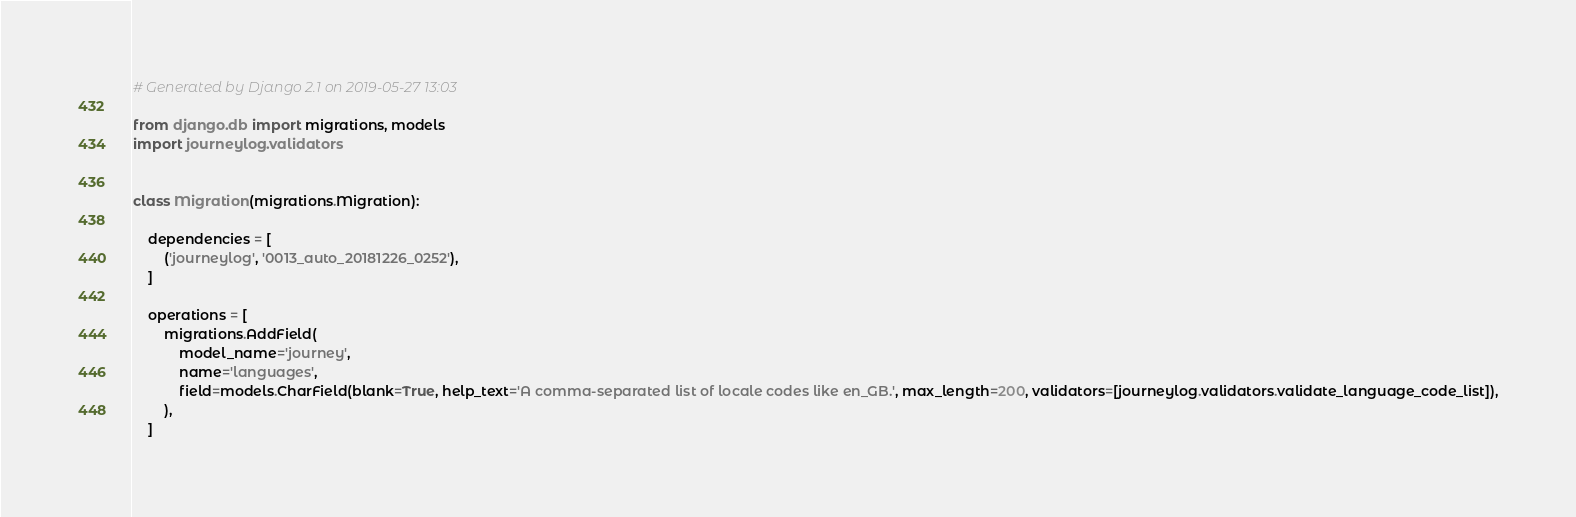Convert code to text. <code><loc_0><loc_0><loc_500><loc_500><_Python_># Generated by Django 2.1 on 2019-05-27 13:03

from django.db import migrations, models
import journeylog.validators


class Migration(migrations.Migration):

    dependencies = [
        ('journeylog', '0013_auto_20181226_0252'),
    ]

    operations = [
        migrations.AddField(
            model_name='journey',
            name='languages',
            field=models.CharField(blank=True, help_text='A comma-separated list of locale codes like en_GB.', max_length=200, validators=[journeylog.validators.validate_language_code_list]),
        ),
    ]
</code> 